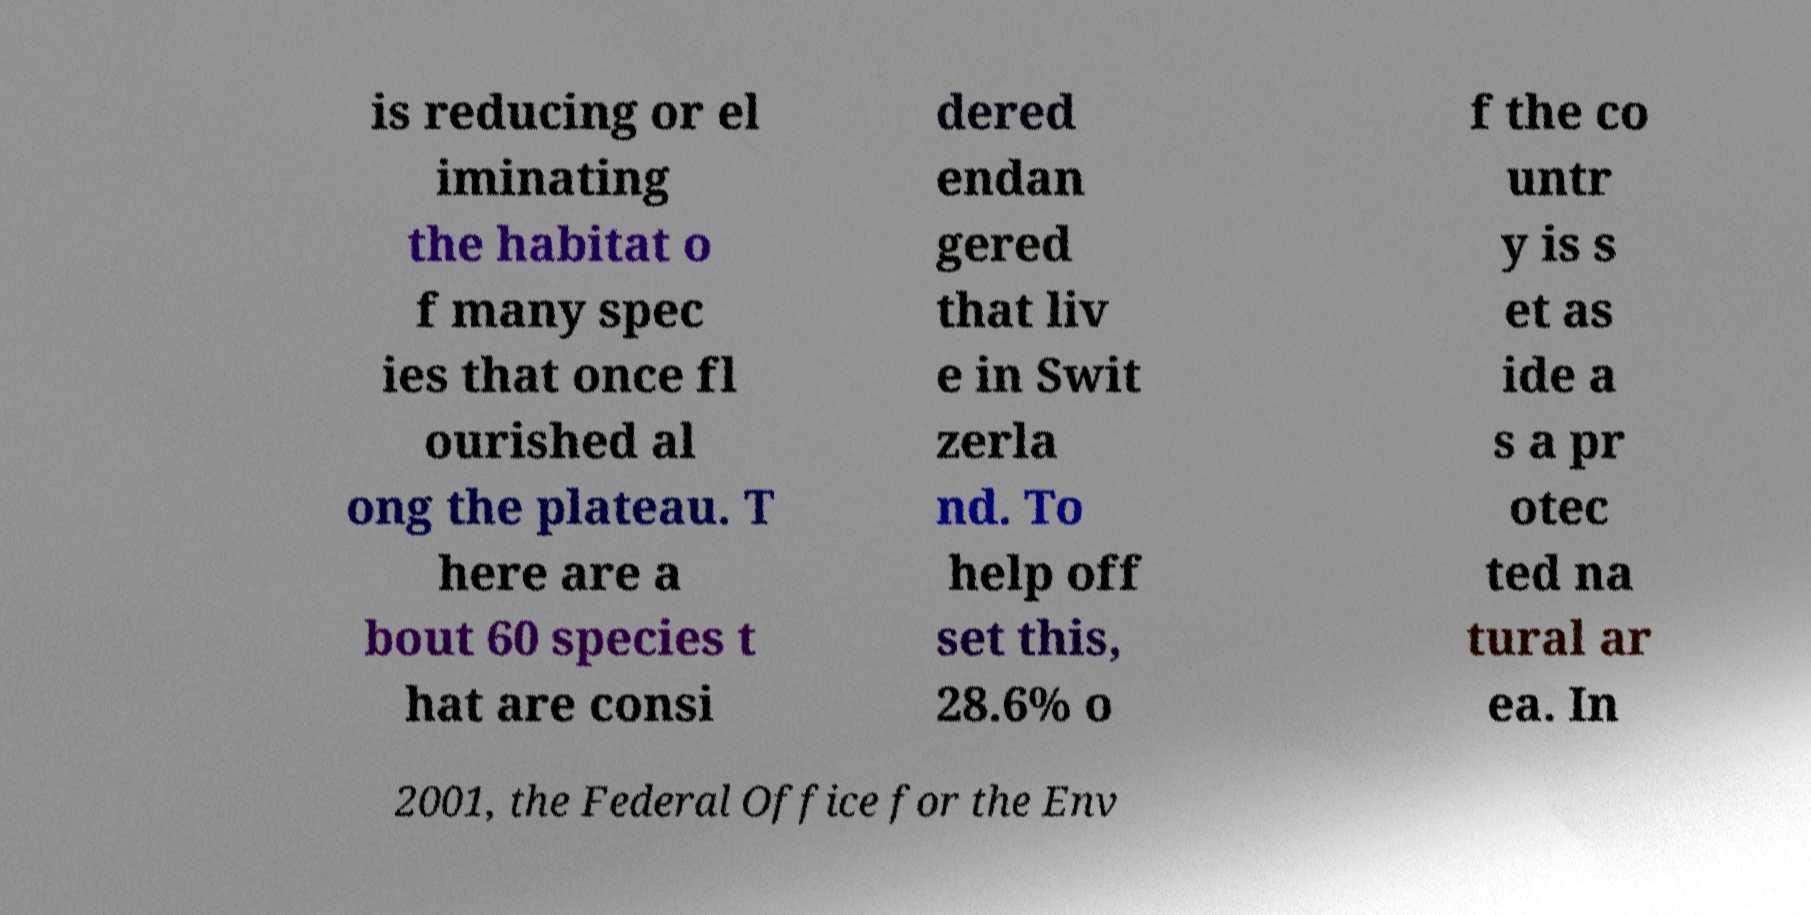Can you read and provide the text displayed in the image?This photo seems to have some interesting text. Can you extract and type it out for me? is reducing or el iminating the habitat o f many spec ies that once fl ourished al ong the plateau. T here are a bout 60 species t hat are consi dered endan gered that liv e in Swit zerla nd. To help off set this, 28.6% o f the co untr y is s et as ide a s a pr otec ted na tural ar ea. In 2001, the Federal Office for the Env 